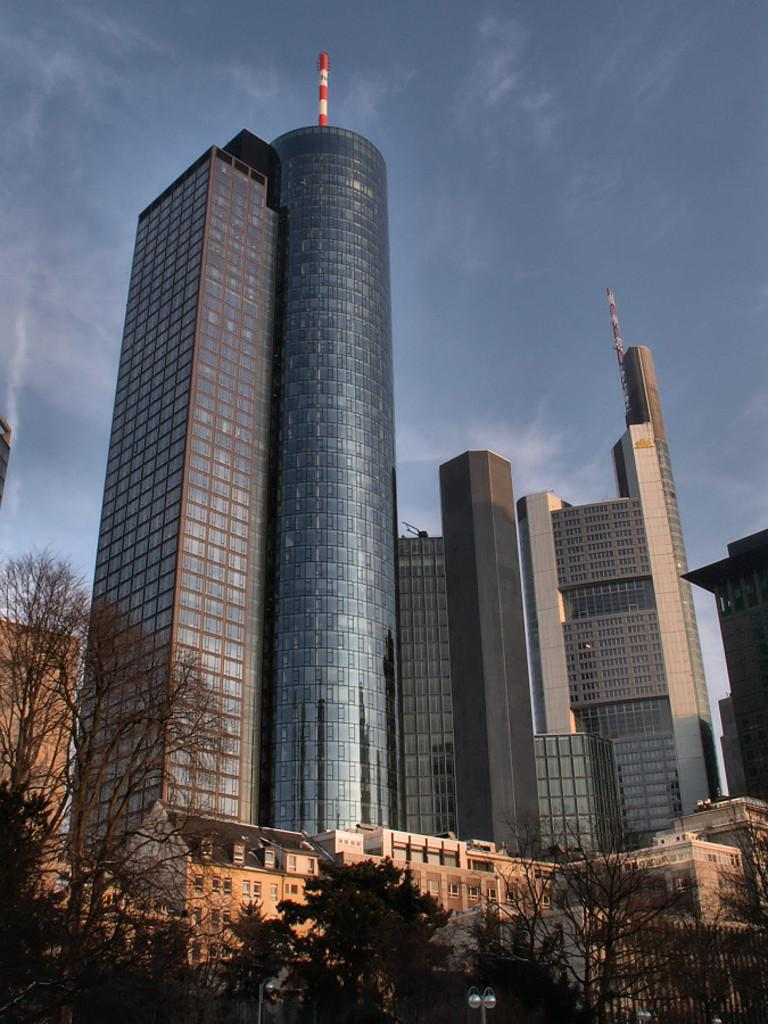What type of vegetation is visible in the front of the image? There are trees in the front of the image. What type of structures can be seen in the background of the image? There are buildings in the background of the image. What is the condition of the sky in the image? The sky is cloudy in the image. Can you tell me how many oranges are hanging from the trees in the image? There are no oranges present in the image; it features trees without any visible fruit. Is there a girl playing near the trees in the image? There is no girl present in the image; it only shows trees and buildings. 